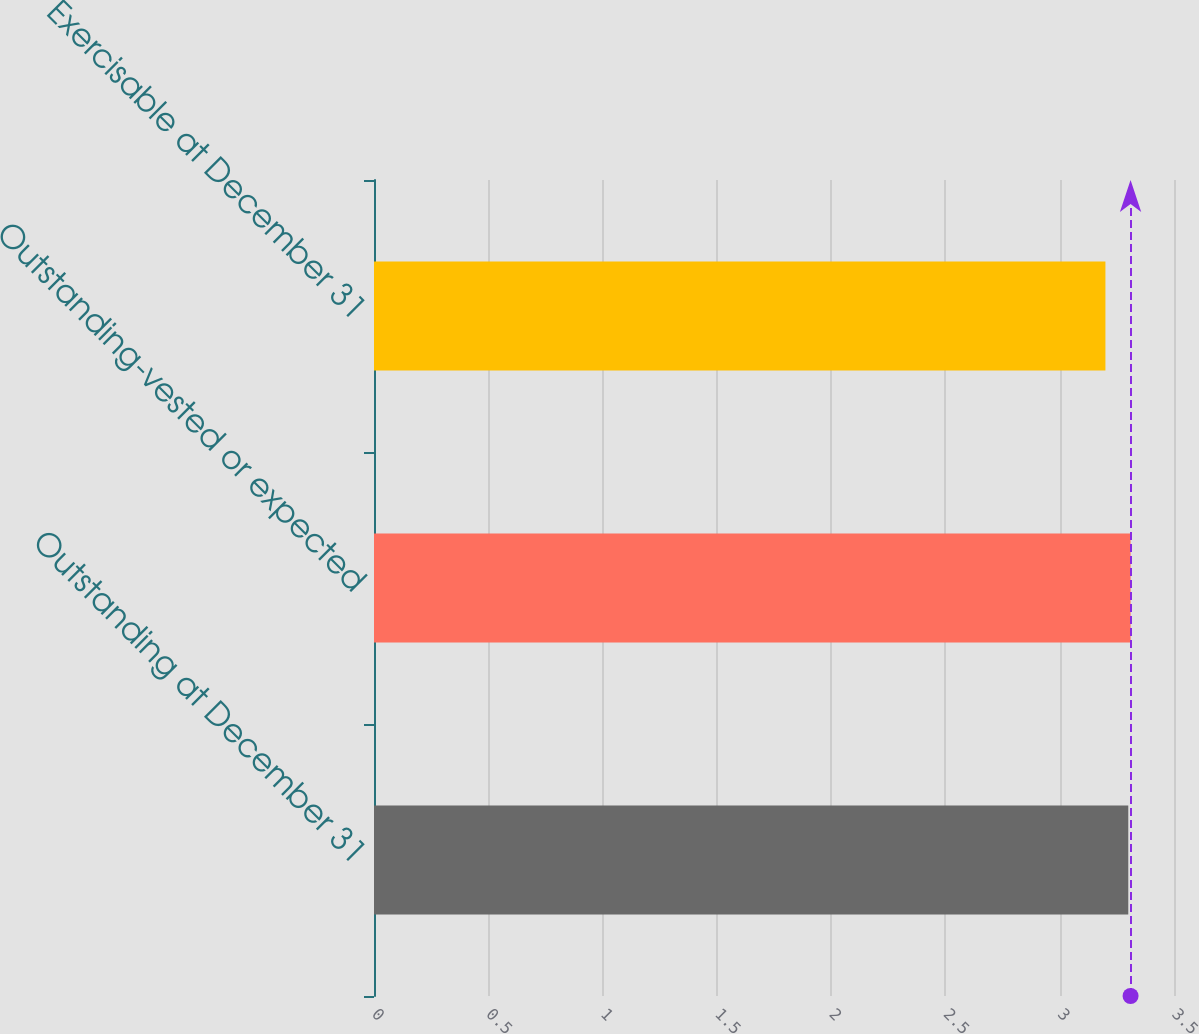<chart> <loc_0><loc_0><loc_500><loc_500><bar_chart><fcel>Outstanding at December 31<fcel>Outstanding-vested or expected<fcel>Exercisable at December 31<nl><fcel>3.3<fcel>3.31<fcel>3.2<nl></chart> 